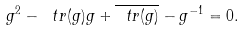Convert formula to latex. <formula><loc_0><loc_0><loc_500><loc_500>g ^ { 2 } - \ t r ( g ) g + \overline { \ t r ( g ) } - g ^ { - 1 } = 0 .</formula> 